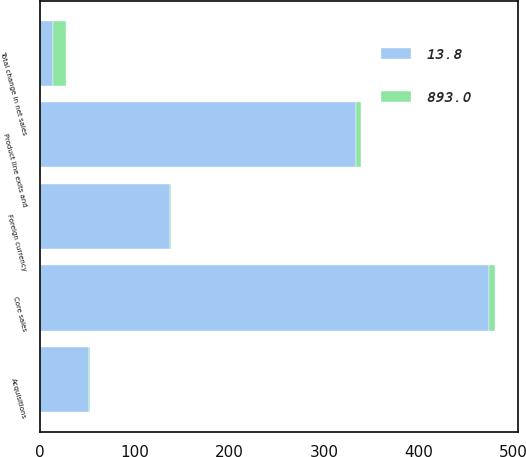<chart> <loc_0><loc_0><loc_500><loc_500><stacked_bar_chart><ecel><fcel>Core sales<fcel>Foreign currency<fcel>Product line exits and<fcel>Acquisitions<fcel>Total change in net sales<nl><fcel>13.8<fcel>474<fcel>136.7<fcel>334.3<fcel>52<fcel>13.8<nl><fcel>893<fcel>7.3<fcel>2.1<fcel>5.2<fcel>0.8<fcel>13.8<nl></chart> 